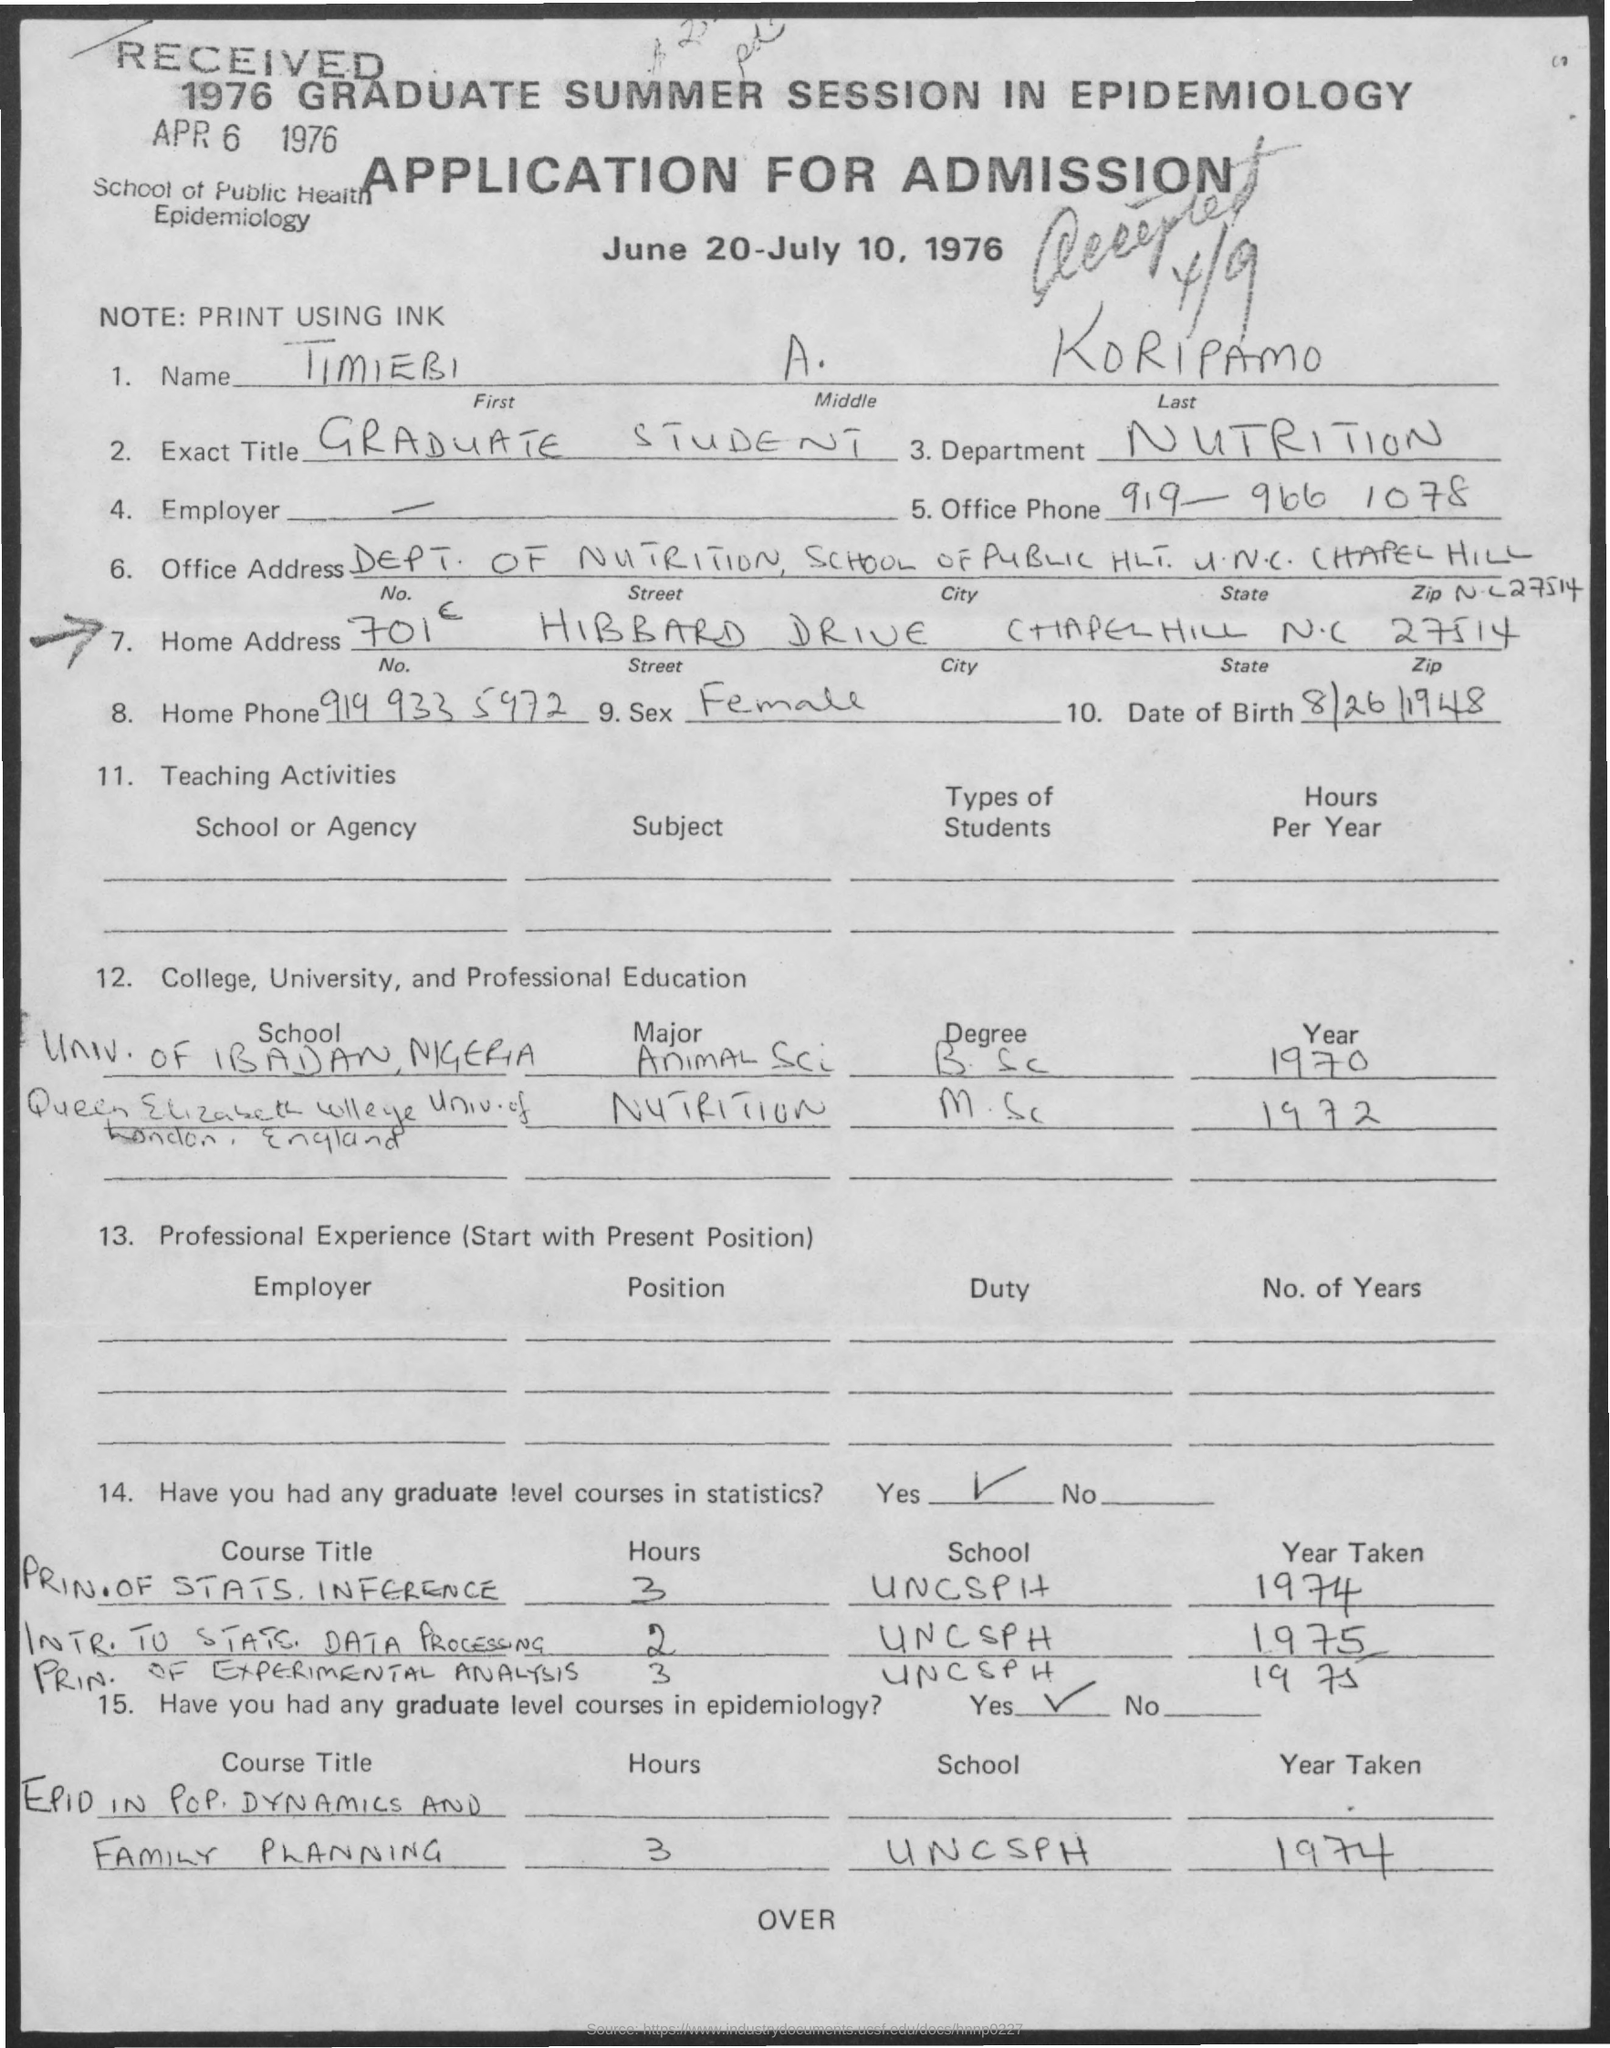Specify some key components in this picture. The title of the document is Application for Admission. I am a graduate student. The City is Chapel Hill. What is the State? North Carolina. The individual's first name is Timiebi. 